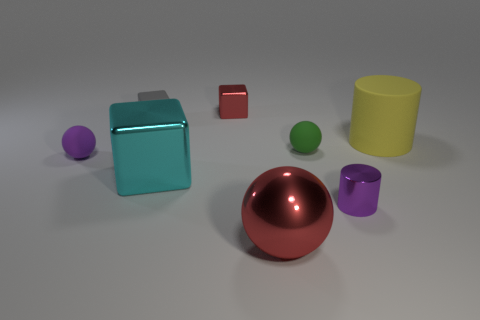Subtract all tiny red blocks. How many blocks are left? 2 Subtract all purple spheres. How many spheres are left? 2 Add 1 tiny gray cubes. How many objects exist? 9 Subtract all spheres. How many objects are left? 5 Add 4 green rubber things. How many green rubber things are left? 5 Add 7 matte cubes. How many matte cubes exist? 8 Subtract 1 red spheres. How many objects are left? 7 Subtract 1 cubes. How many cubes are left? 2 Subtract all green balls. Subtract all purple cylinders. How many balls are left? 2 Subtract all purple cylinders. How many purple spheres are left? 1 